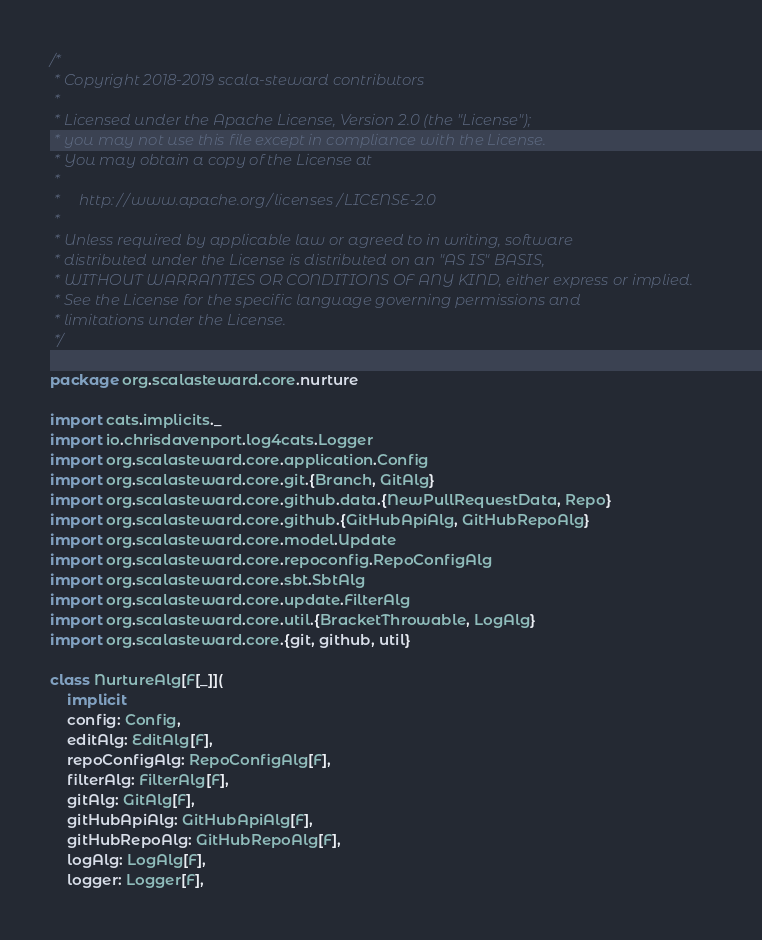Convert code to text. <code><loc_0><loc_0><loc_500><loc_500><_Scala_>/*
 * Copyright 2018-2019 scala-steward contributors
 *
 * Licensed under the Apache License, Version 2.0 (the "License");
 * you may not use this file except in compliance with the License.
 * You may obtain a copy of the License at
 *
 *     http://www.apache.org/licenses/LICENSE-2.0
 *
 * Unless required by applicable law or agreed to in writing, software
 * distributed under the License is distributed on an "AS IS" BASIS,
 * WITHOUT WARRANTIES OR CONDITIONS OF ANY KIND, either express or implied.
 * See the License for the specific language governing permissions and
 * limitations under the License.
 */

package org.scalasteward.core.nurture

import cats.implicits._
import io.chrisdavenport.log4cats.Logger
import org.scalasteward.core.application.Config
import org.scalasteward.core.git.{Branch, GitAlg}
import org.scalasteward.core.github.data.{NewPullRequestData, Repo}
import org.scalasteward.core.github.{GitHubApiAlg, GitHubRepoAlg}
import org.scalasteward.core.model.Update
import org.scalasteward.core.repoconfig.RepoConfigAlg
import org.scalasteward.core.sbt.SbtAlg
import org.scalasteward.core.update.FilterAlg
import org.scalasteward.core.util.{BracketThrowable, LogAlg}
import org.scalasteward.core.{git, github, util}

class NurtureAlg[F[_]](
    implicit
    config: Config,
    editAlg: EditAlg[F],
    repoConfigAlg: RepoConfigAlg[F],
    filterAlg: FilterAlg[F],
    gitAlg: GitAlg[F],
    gitHubApiAlg: GitHubApiAlg[F],
    gitHubRepoAlg: GitHubRepoAlg[F],
    logAlg: LogAlg[F],
    logger: Logger[F],</code> 